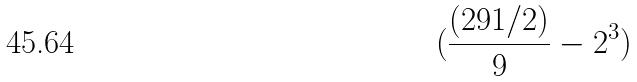Convert formula to latex. <formula><loc_0><loc_0><loc_500><loc_500>( \frac { ( 2 9 1 / 2 ) } { 9 } - 2 ^ { 3 } )</formula> 